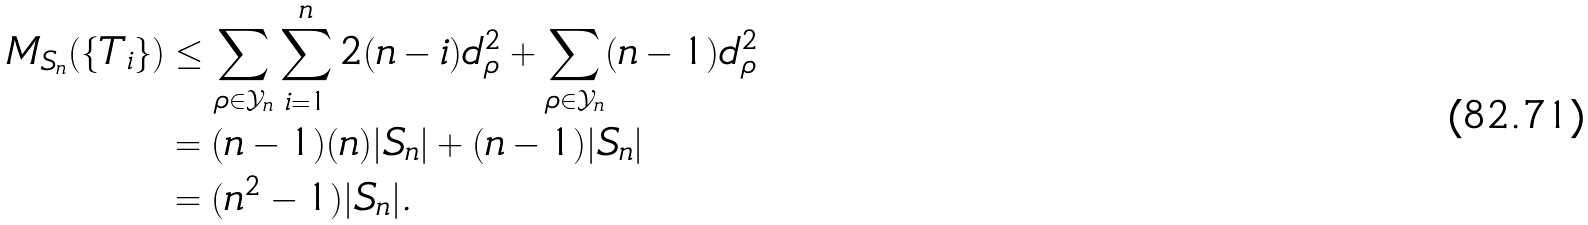<formula> <loc_0><loc_0><loc_500><loc_500>M _ { S _ { n } } ( \{ T _ { i } \} ) & \leq \sum _ { \rho \in { \mathcal { Y } } _ { n } } \sum _ { i = 1 } ^ { n } 2 ( n - i ) d _ { \rho } ^ { 2 } + \sum _ { \rho \in { \mathcal { Y } } _ { n } } ( n - 1 ) d _ { \rho } ^ { 2 } \\ & = ( n - 1 ) ( n ) | S _ { n } | + ( n - 1 ) | S _ { n } | \\ & = ( n ^ { 2 } - 1 ) | S _ { n } | .</formula> 